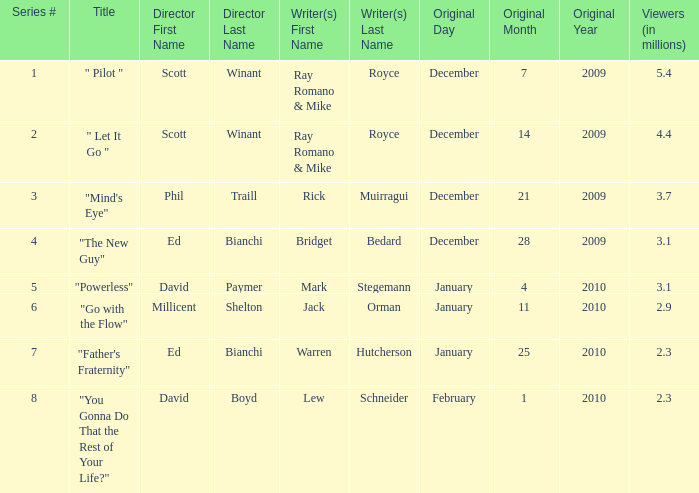What is the original air date of "Powerless"? January4,2010. 